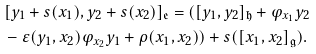<formula> <loc_0><loc_0><loc_500><loc_500>& [ y _ { 1 } + s ( x _ { 1 } ) , y _ { 2 } + s ( x _ { 2 } ) ] _ { \mathfrak { e } } = ( [ y _ { 1 } , y _ { 2 } ] _ { \mathfrak { h } } + \varphi _ { x _ { 1 } } y _ { 2 } \\ & - \varepsilon ( y _ { 1 } , x _ { 2 } ) \varphi _ { x _ { 2 } } y _ { 1 } + \rho ( x _ { 1 } , x _ { 2 } ) ) + s ( [ x _ { 1 } , x _ { 2 } ] _ { \mathfrak { g } } ) .</formula> 